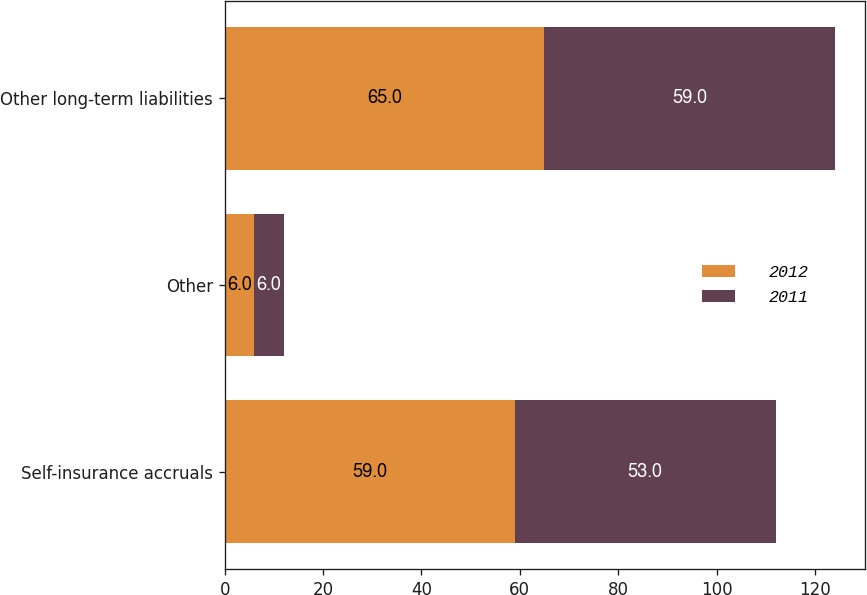Convert chart. <chart><loc_0><loc_0><loc_500><loc_500><stacked_bar_chart><ecel><fcel>Self-insurance accruals<fcel>Other<fcel>Other long-term liabilities<nl><fcel>2012<fcel>59<fcel>6<fcel>65<nl><fcel>2011<fcel>53<fcel>6<fcel>59<nl></chart> 